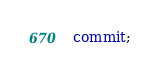<code> <loc_0><loc_0><loc_500><loc_500><_SQL_>commit;</code> 